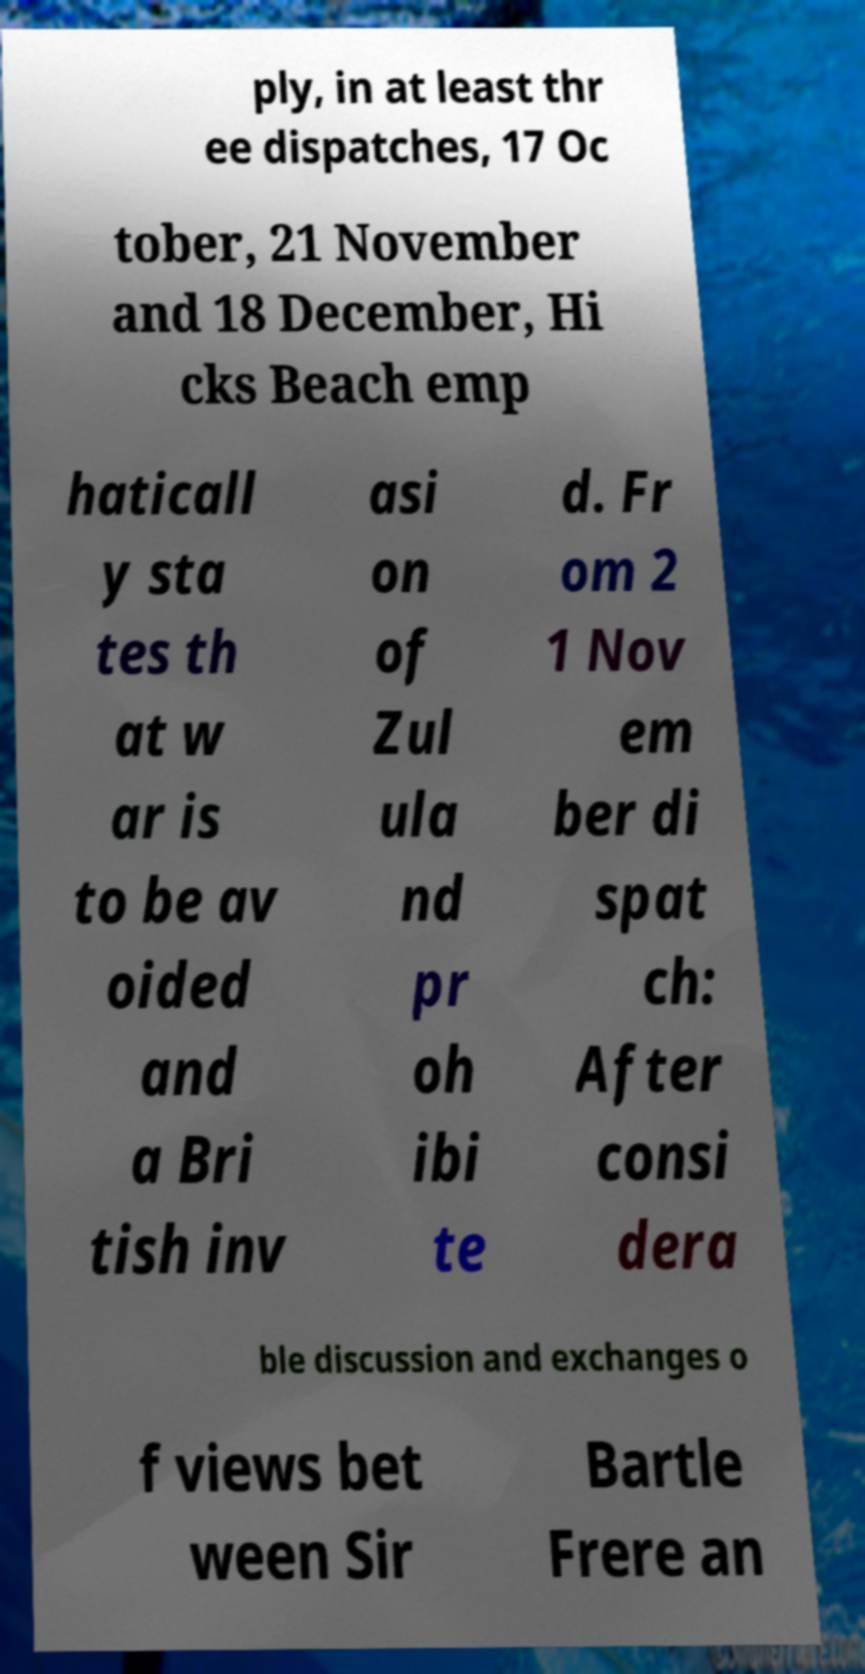There's text embedded in this image that I need extracted. Can you transcribe it verbatim? ply, in at least thr ee dispatches, 17 Oc tober, 21 November and 18 December, Hi cks Beach emp haticall y sta tes th at w ar is to be av oided and a Bri tish inv asi on of Zul ula nd pr oh ibi te d. Fr om 2 1 Nov em ber di spat ch: After consi dera ble discussion and exchanges o f views bet ween Sir Bartle Frere an 